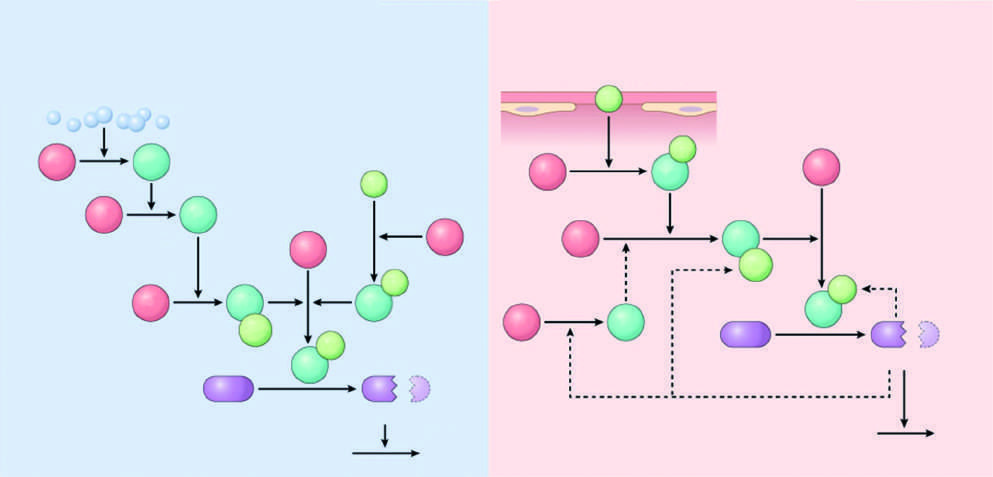do the light green polypeptides correspond to cofactors?
Answer the question using a single word or phrase. Yes 